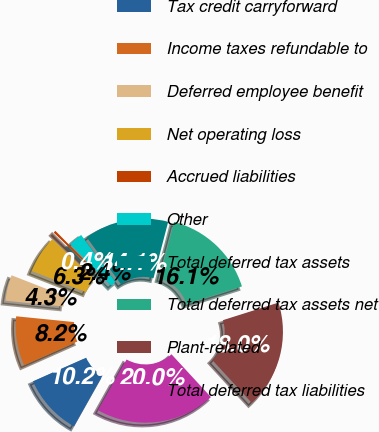Convert chart. <chart><loc_0><loc_0><loc_500><loc_500><pie_chart><fcel>Tax credit carryforward<fcel>Income taxes refundable to<fcel>Deferred employee benefit<fcel>Net operating loss<fcel>Accrued liabilities<fcel>Other<fcel>Total deferred tax assets<fcel>Total deferred tax assets net<fcel>Plant-related<fcel>Total deferred tax liabilities<nl><fcel>10.2%<fcel>8.24%<fcel>4.32%<fcel>6.28%<fcel>0.4%<fcel>2.36%<fcel>14.11%<fcel>16.07%<fcel>18.03%<fcel>19.99%<nl></chart> 